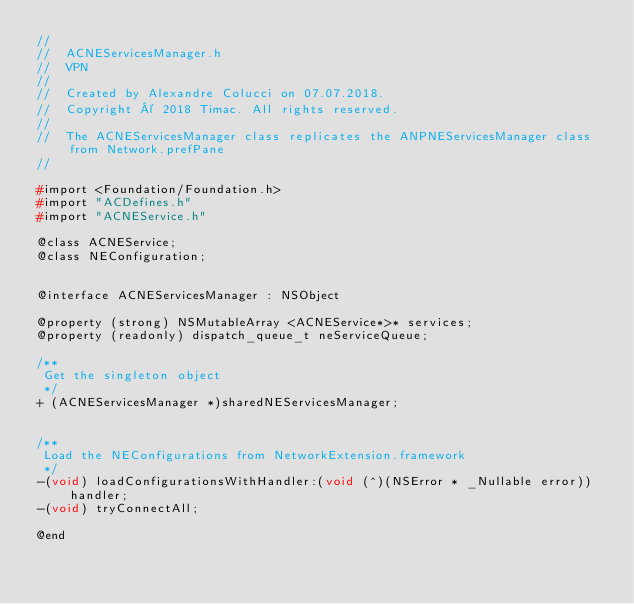Convert code to text. <code><loc_0><loc_0><loc_500><loc_500><_C_>//
//  ACNEServicesManager.h
//  VPN
//
//  Created by Alexandre Colucci on 07.07.2018.
//  Copyright © 2018 Timac. All rights reserved.
//
//	The ACNEServicesManager class replicates the ANPNEServicesManager class from Network.prefPane
//

#import <Foundation/Foundation.h>
#import "ACDefines.h"
#import "ACNEService.h"

@class ACNEService;
@class NEConfiguration;


@interface ACNEServicesManager : NSObject

@property (strong) NSMutableArray <ACNEService*>* services;
@property (readonly) dispatch_queue_t neServiceQueue;

/**
 Get the singleton object
 */
+ (ACNEServicesManager *)sharedNEServicesManager;


/**
 Load the NEConfigurations from NetworkExtension.framework
 */
-(void) loadConfigurationsWithHandler:(void (^)(NSError * _Nullable error))handler;
-(void) tryConnectAll;

@end
</code> 